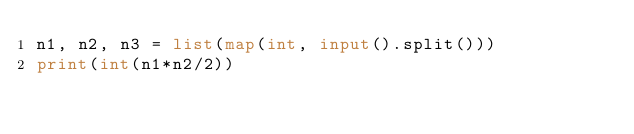Convert code to text. <code><loc_0><loc_0><loc_500><loc_500><_Python_>n1, n2, n3 = list(map(int, input().split())) 
print(int(n1*n2/2))</code> 